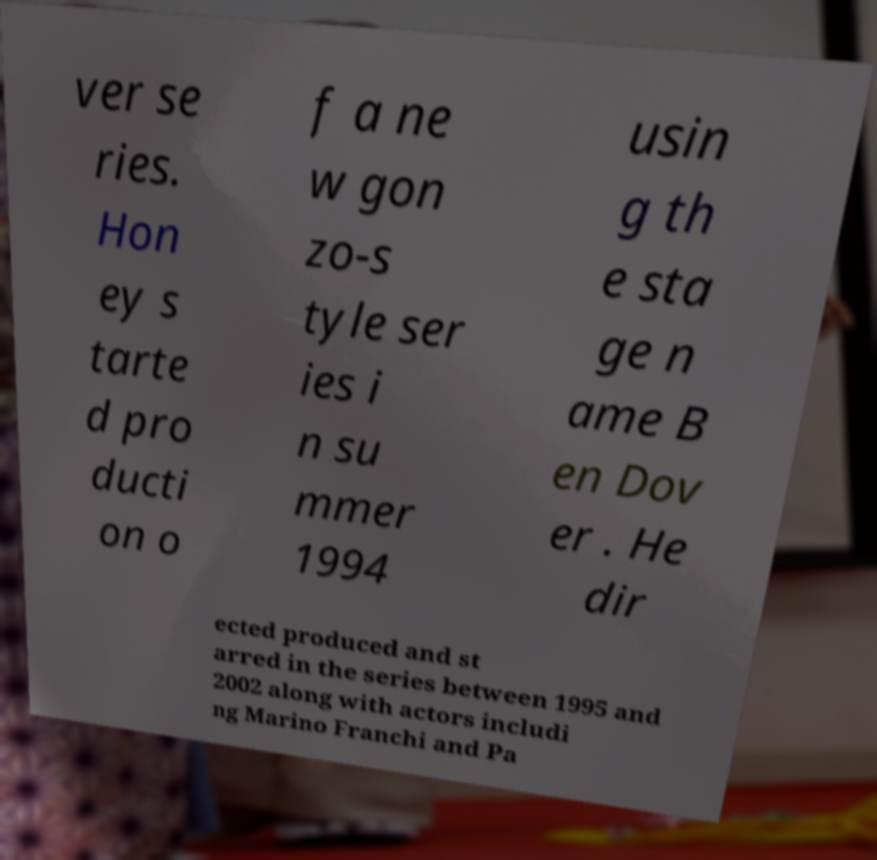Could you assist in decoding the text presented in this image and type it out clearly? ver se ries. Hon ey s tarte d pro ducti on o f a ne w gon zo-s tyle ser ies i n su mmer 1994 usin g th e sta ge n ame B en Dov er . He dir ected produced and st arred in the series between 1995 and 2002 along with actors includi ng Marino Franchi and Pa 